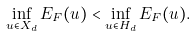<formula> <loc_0><loc_0><loc_500><loc_500>\inf _ { u \in X _ { d } } E _ { F } ( u ) < \inf _ { u \in H _ { d } } E _ { F } ( u ) .</formula> 